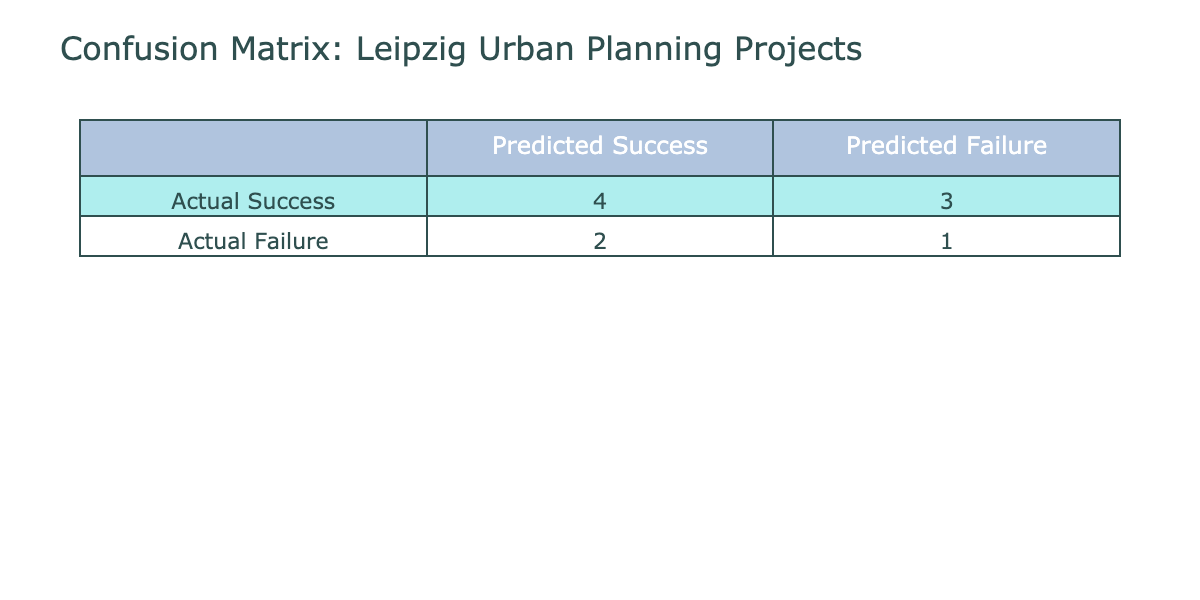What is the count of projects that were predicted to be a success but were actually failures? In the table, we need to look for instances where 'Predicted Success' is 1 but 'Actual Failure' is 1. The project names that fit this criteria are "Städtische Bibliothek Renovation," "Batterie Park Development," "Housing at AstraZeneca Site," and "Neue Leipziger Philharmonie." Counting these gives a total of 4 projects.
Answer: 4 How many projects had successful actual outcomes? We can count the rows where the 'Actual Outcome' is 'Success'. Looking at the table, the projects that fit this criterion are "Leipzig Market Square Redevelopment," "Rosenthaler Vorstadt Housing Project," "Kunstkraftwerk Leipzig," "Altes Landratsamt Restoration," which sums to a total of 4 successful outcomes.
Answer: 4 What is the total number of projects that were both predicted to succeed and actually succeeded? We need to count the instances where both 'Predicted Success' and 'Actual Success' are 1. In the table, this applies to projects "Leipzig Market Square Redevelopment," "Rosenthaler Vorstadt Housing Project," "Kunstkraftwerk Leipzig," and "Altes Landratsamt Restoration," which gives us a total of 4 projects.
Answer: 4 Did any projects have a failure in both actual and predictive outcomes? Yes, we can verify this by looking for instances where both 'Actual Outcome' and 'Predictive Outcome' are 'Failure.' In the table, "City Center Green Space Initiative" is the only project that fits this condition, therefore the answer is yes.
Answer: Yes What is the difference between the number of successful actual outcomes and the number of predicted successes? To find this, first we count the 'Actual Success' values which is 4, and for the 'Predicted Success' values, we also count them to be 5. The difference is 5 - 4 = 1, indicating one more project was predicted to succeed than actually did.
Answer: 1 How many projects were predicted to fail but actually succeeded? We look for where 'Predicted Failure' is 1 and 'Actual Success' is also 1. The columns related to these projects are "Städtische Bibliothek Renovation," "Leipzig City Tunnel Expansion," "Neue Leipziger Philharmonie," and "Batterie Park Development," which gives us a total of 3 projects.
Answer: 3 What percentage of projects predicted as successes actually succeeded? We count the predicted successes, which is 5, and of those, 4 actually succeeded. The percentage can be calculated by taking (4/5) * 100, which equals 80%.
Answer: 80% What is the total number of predicted failures regardless of actual outcomes? This can be determined by counting the occurrences of 'Predicted Failure' which corresponds to the projects “Städtische Bibliothek Renovation,” “Leipzig City Tunnel Expansion,” “City Center Green Space Initiative,” and “Neue Leipziger Philharmonie” which sums up to 4 projects.
Answer: 4 Do all projects with successful actual outcomes have predictive success? No, we see that "Städtische Bibliothek Renovation," "Leipzig City Tunnel Expansion," and "Neue Leipziger Philharmonie" had successful actual outcomes but did not predict success, indicating that not all successful projects were predicted to succeed.
Answer: No 